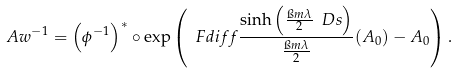<formula> <loc_0><loc_0><loc_500><loc_500>\ A w ^ { - 1 } = \left ( { \phi ^ { - 1 } } \right ) ^ { * } \circ \exp \left ( \ F d i f f { \frac { \sinh \left ( \frac { \i m \lambda } { 2 } \ D s \right ) } { \frac { \i m \lambda } { 2 } } ( A _ { 0 } ) - A _ { 0 } } \right ) .</formula> 